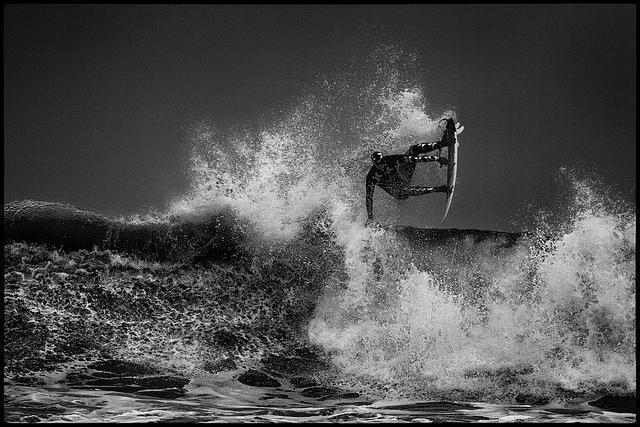How many feet does the surfer have touching the board?
Give a very brief answer. 2. How many of the birds are making noise?
Give a very brief answer. 0. 